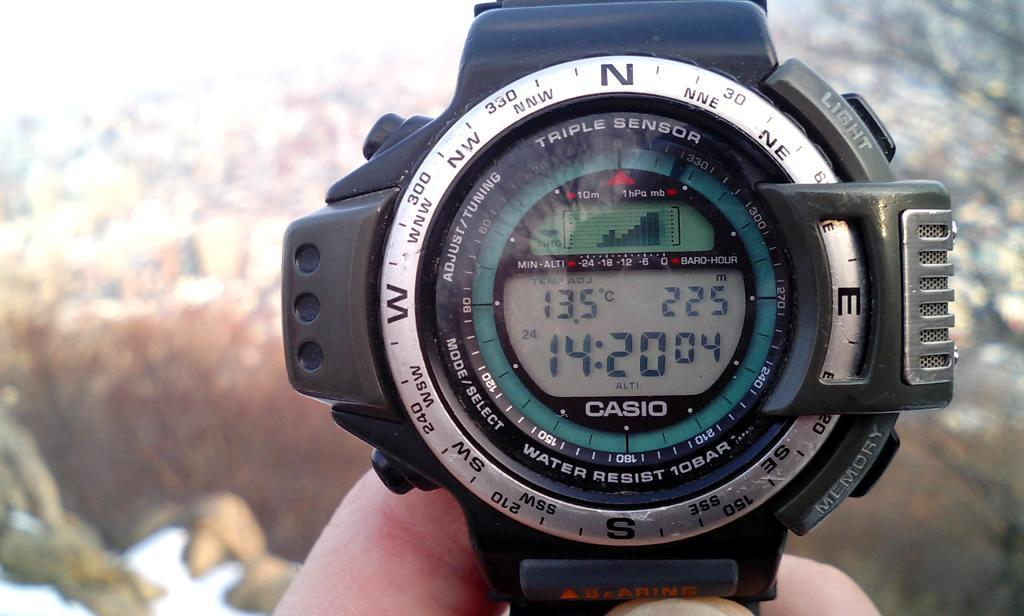<image>
Offer a succinct explanation of the picture presented. A person is holding a watch that says Casio. 